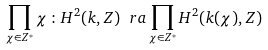Convert formula to latex. <formula><loc_0><loc_0><loc_500><loc_500>\prod _ { \chi \in Z ^ { * } } \chi \, \colon H ^ { 2 } ( k , Z ) \ r a \prod _ { \chi \in Z ^ { * } } H ^ { 2 } ( k ( \chi ) , Z )</formula> 